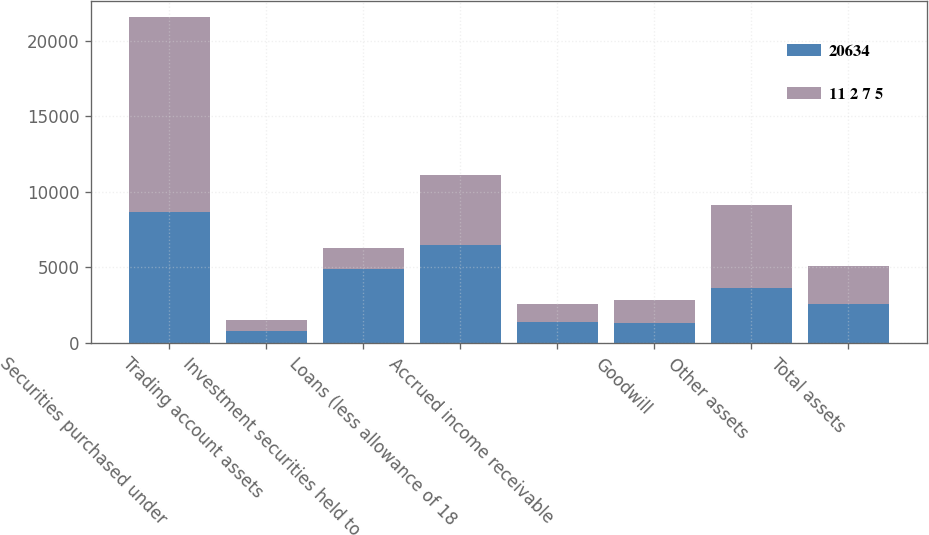<chart> <loc_0><loc_0><loc_500><loc_500><stacked_bar_chart><ecel><fcel>Securities purchased under<fcel>Trading account assets<fcel>Investment securities held to<fcel>Loans (less allowance of 18<fcel>Accrued income receivable<fcel>Goodwill<fcel>Other assets<fcel>Total assets<nl><fcel>20634<fcel>8679<fcel>764<fcel>4891<fcel>6464<fcel>1364<fcel>1337<fcel>3619<fcel>2558<nl><fcel>11 2 7 5<fcel>12878<fcel>745<fcel>1400<fcel>4611<fcel>1204<fcel>1497<fcel>5477<fcel>2558<nl></chart> 